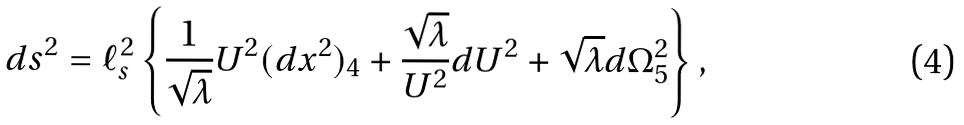Convert formula to latex. <formula><loc_0><loc_0><loc_500><loc_500>d s ^ { 2 } = \ell _ { s } ^ { 2 } \left \{ \frac { 1 } { \sqrt { \lambda } } U ^ { 2 } ( d x ^ { 2 } ) _ { 4 } + \frac { \sqrt { \lambda } } { U ^ { 2 } } d U ^ { 2 } + \sqrt { \lambda } d \Omega _ { 5 } ^ { 2 } \right \} ,</formula> 